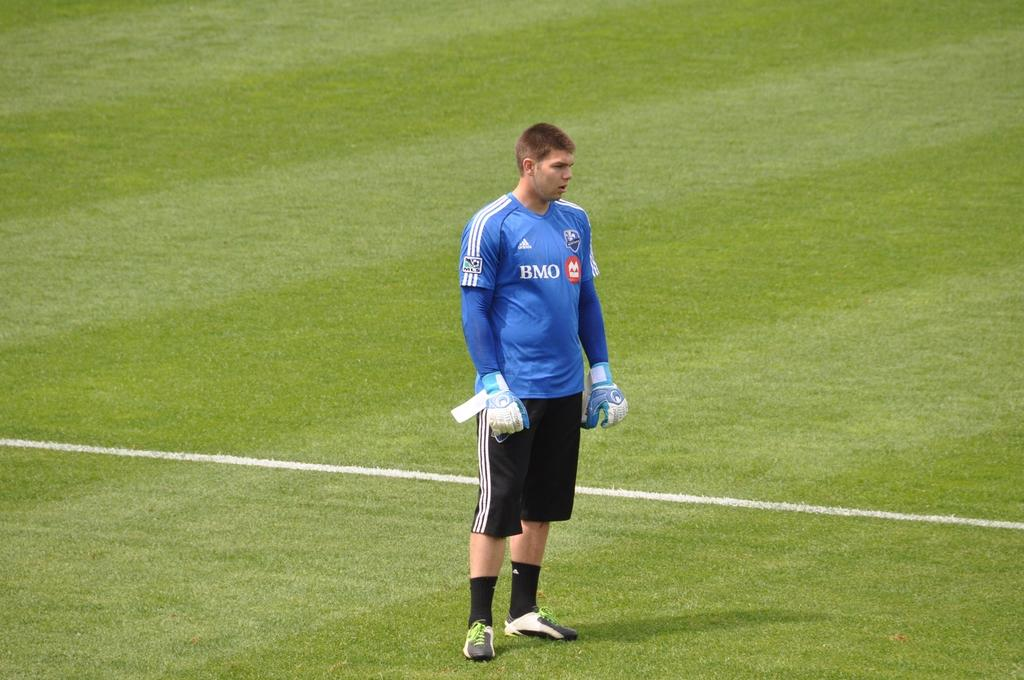<image>
Relay a brief, clear account of the picture shown. A player wearing a BMO shirt stands on a grass field. 